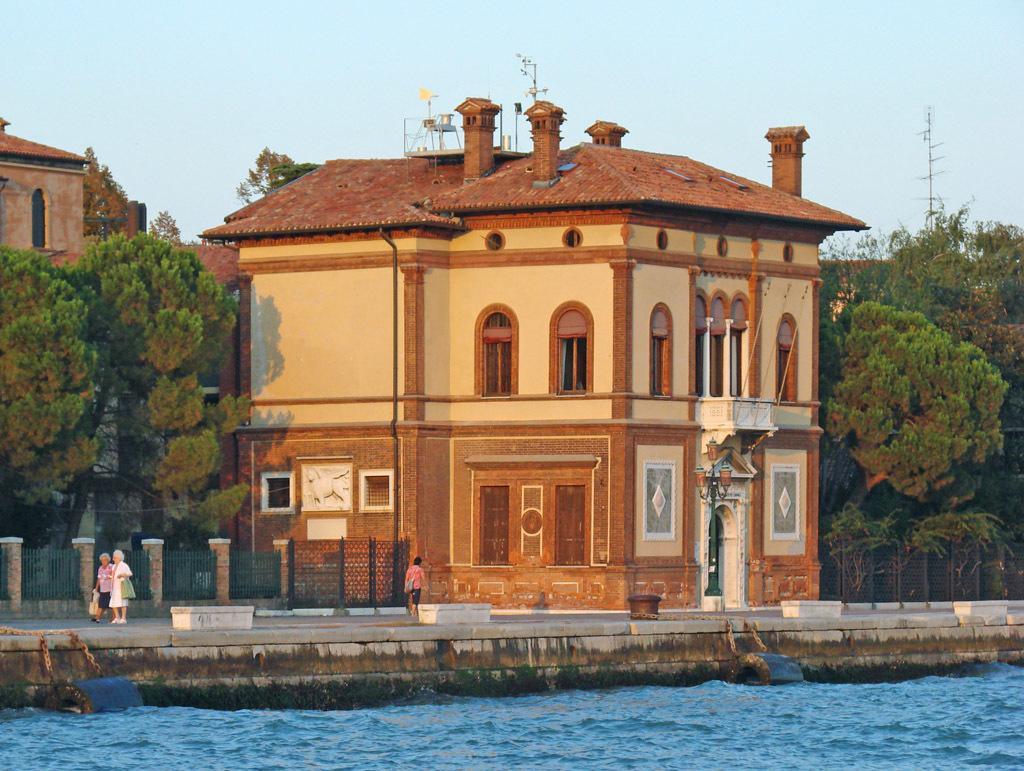Please provide a concise description of this image. In the center of the image there are buildings. At the bottom we can see people walking and there is water. In the background there are trees, pole and sky. We can see fence. 